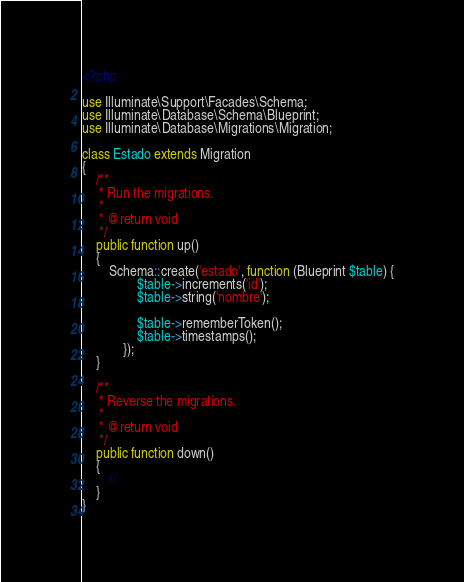Convert code to text. <code><loc_0><loc_0><loc_500><loc_500><_PHP_><?php

use Illuminate\Support\Facades\Schema;
use Illuminate\Database\Schema\Blueprint;
use Illuminate\Database\Migrations\Migration;

class Estado extends Migration
{
    /**
     * Run the migrations.
     *
     * @return void
     */
    public function up()
    {
        Schema::create('estado', function (Blueprint $table) {
                $table->increments('id');
                $table->string('nombre');

                $table->rememberToken();
                $table->timestamps();
            });
    }

    /**
     * Reverse the migrations.
     *
     * @return void
     */
    public function down()
    {
        //
    }
}
</code> 